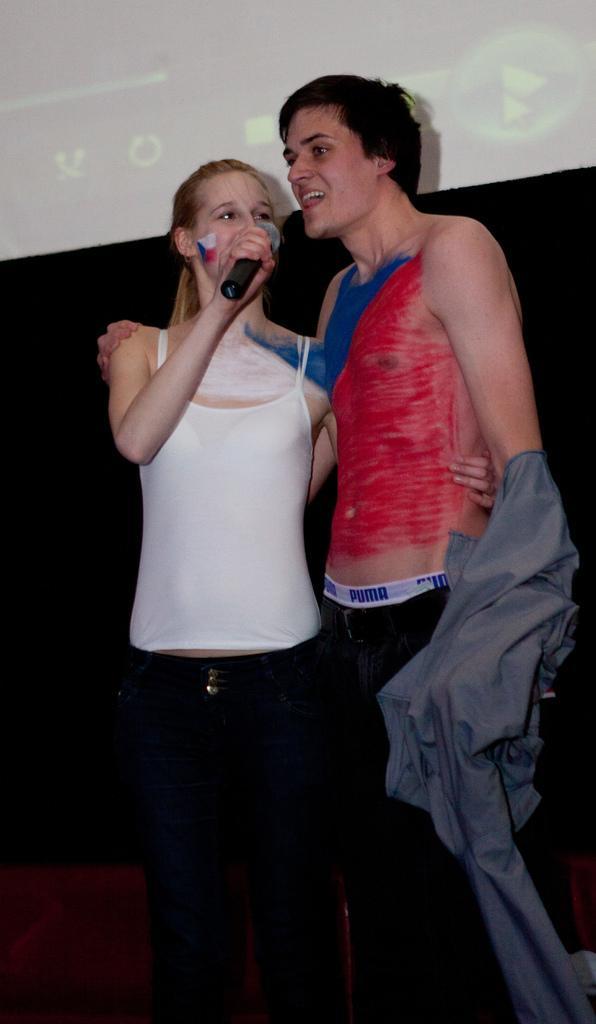Describe this image in one or two sentences. This image is taken indoors. In the middle of the image a man and a woman are standing on the floor and a woman is holding a mic in her hand and a man is talking. In the background there is a screen. 